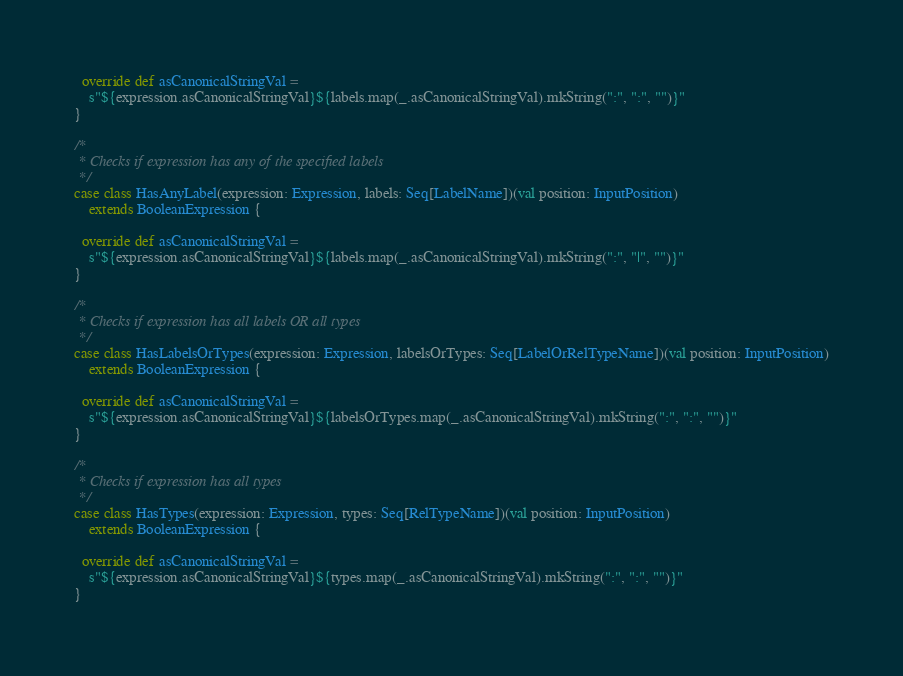Convert code to text. <code><loc_0><loc_0><loc_500><loc_500><_Scala_>
  override def asCanonicalStringVal =
    s"${expression.asCanonicalStringVal}${labels.map(_.asCanonicalStringVal).mkString(":", ":", "")}"
}

/*
 * Checks if expression has any of the specified labels
 */
case class HasAnyLabel(expression: Expression, labels: Seq[LabelName])(val position: InputPosition)
    extends BooleanExpression {

  override def asCanonicalStringVal =
    s"${expression.asCanonicalStringVal}${labels.map(_.asCanonicalStringVal).mkString(":", "|", "")}"
}

/*
 * Checks if expression has all labels OR all types
 */
case class HasLabelsOrTypes(expression: Expression, labelsOrTypes: Seq[LabelOrRelTypeName])(val position: InputPosition)
    extends BooleanExpression {

  override def asCanonicalStringVal =
    s"${expression.asCanonicalStringVal}${labelsOrTypes.map(_.asCanonicalStringVal).mkString(":", ":", "")}"
}

/*
 * Checks if expression has all types
 */
case class HasTypes(expression: Expression, types: Seq[RelTypeName])(val position: InputPosition)
    extends BooleanExpression {

  override def asCanonicalStringVal =
    s"${expression.asCanonicalStringVal}${types.map(_.asCanonicalStringVal).mkString(":", ":", "")}"
}
</code> 